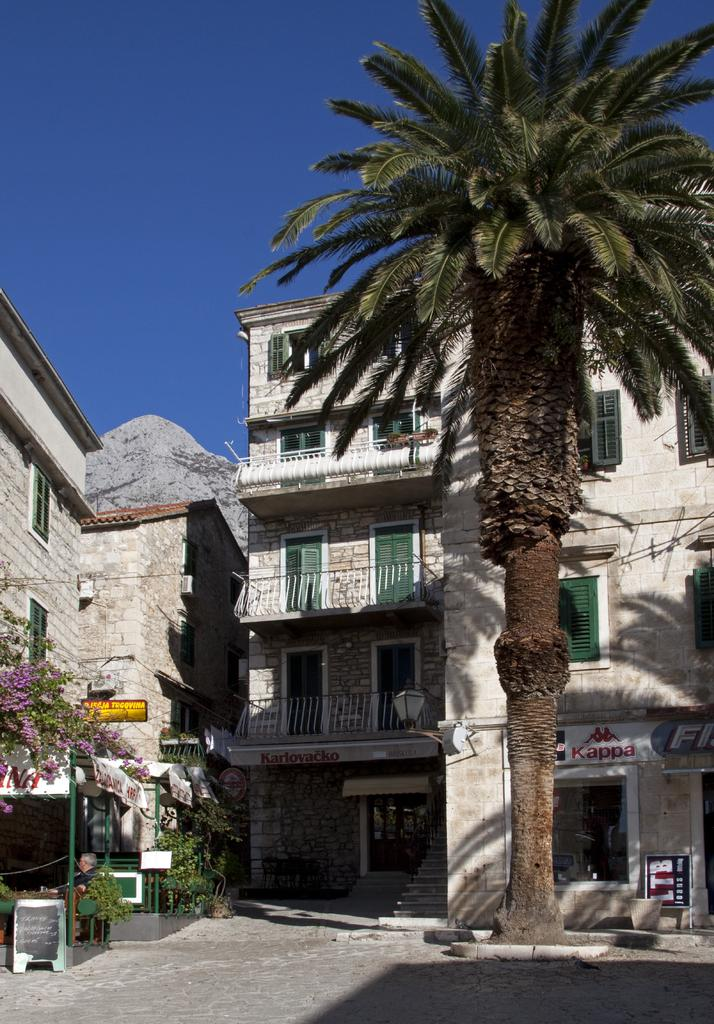<image>
Render a clear and concise summary of the photo. A building in back of a tree that says kappa. 